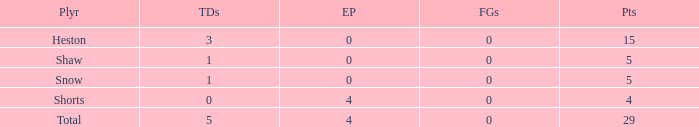What is the sum of all the touchdowns when the player had more than 0 extra points and less than 0 field goals? None. 